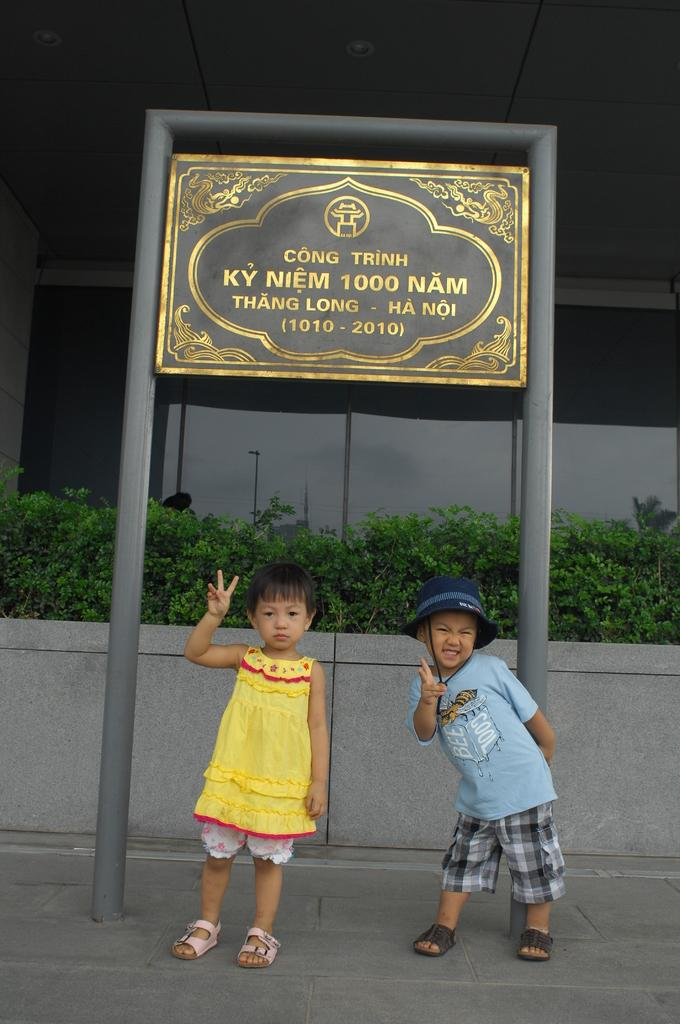How many people are in the image? There are two persons standing in the image. What is the board on a pole used for? The board on a pole has text on it, which suggests it might be used for communication or displaying information. What can be seen in the background of the image? There is a building and plants in the background of the image. What type of jar is being used to capture the reaction of the persons in the image? There is no jar or reaction being captured in the image; it simply shows two people standing near a board on a pole. 